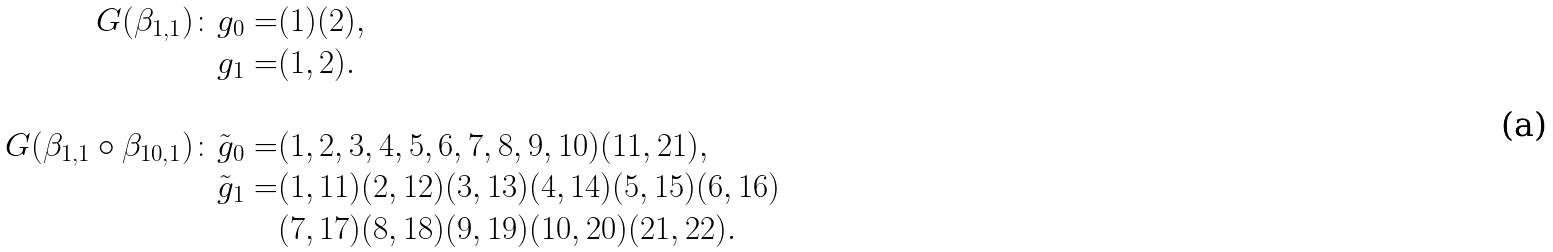Convert formula to latex. <formula><loc_0><loc_0><loc_500><loc_500>G ( \beta _ { 1 , 1 } ) \colon g _ { 0 } = & ( 1 ) ( 2 ) , \\ g _ { 1 } = & ( 1 , 2 ) . \\ \\ G ( \beta _ { 1 , 1 } \circ \beta _ { 1 0 , 1 } ) \colon \tilde { g } _ { 0 } = & ( 1 , 2 , 3 , 4 , 5 , 6 , 7 , 8 , 9 , 1 0 ) ( 1 1 , 2 1 ) , \\ \tilde { g } _ { 1 } = & ( 1 , 1 1 ) ( 2 , 1 2 ) ( 3 , 1 3 ) ( 4 , 1 4 ) ( 5 , 1 5 ) ( 6 , 1 6 ) \\ & ( 7 , 1 7 ) ( 8 , 1 8 ) ( 9 , 1 9 ) ( 1 0 , 2 0 ) ( 2 1 , 2 2 ) . \\</formula> 